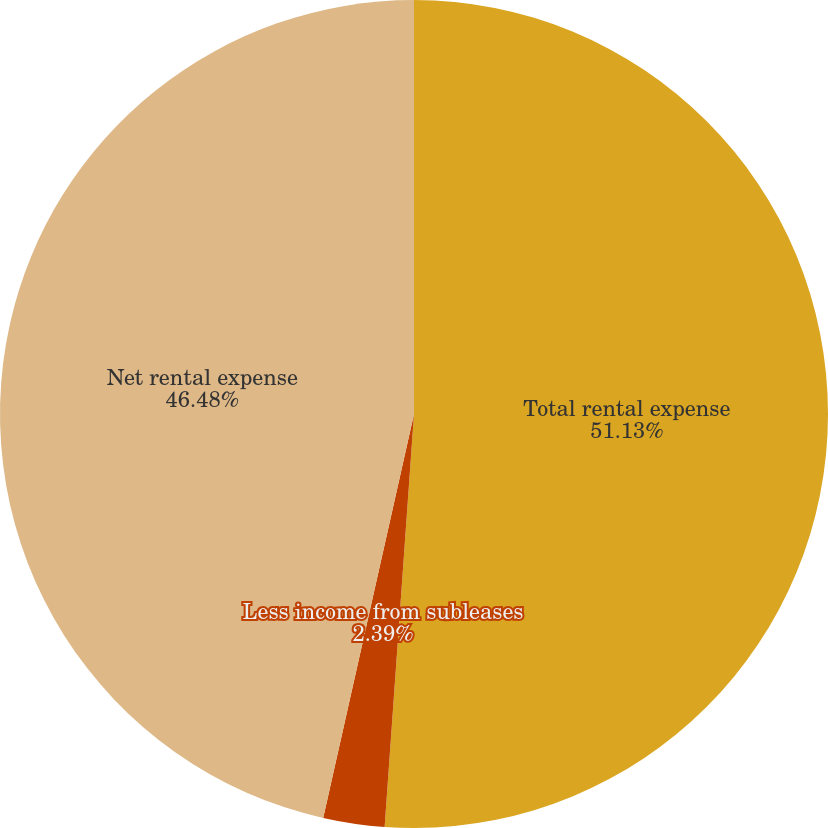<chart> <loc_0><loc_0><loc_500><loc_500><pie_chart><fcel>Total rental expense<fcel>Less income from subleases<fcel>Net rental expense<nl><fcel>51.13%<fcel>2.39%<fcel>46.48%<nl></chart> 